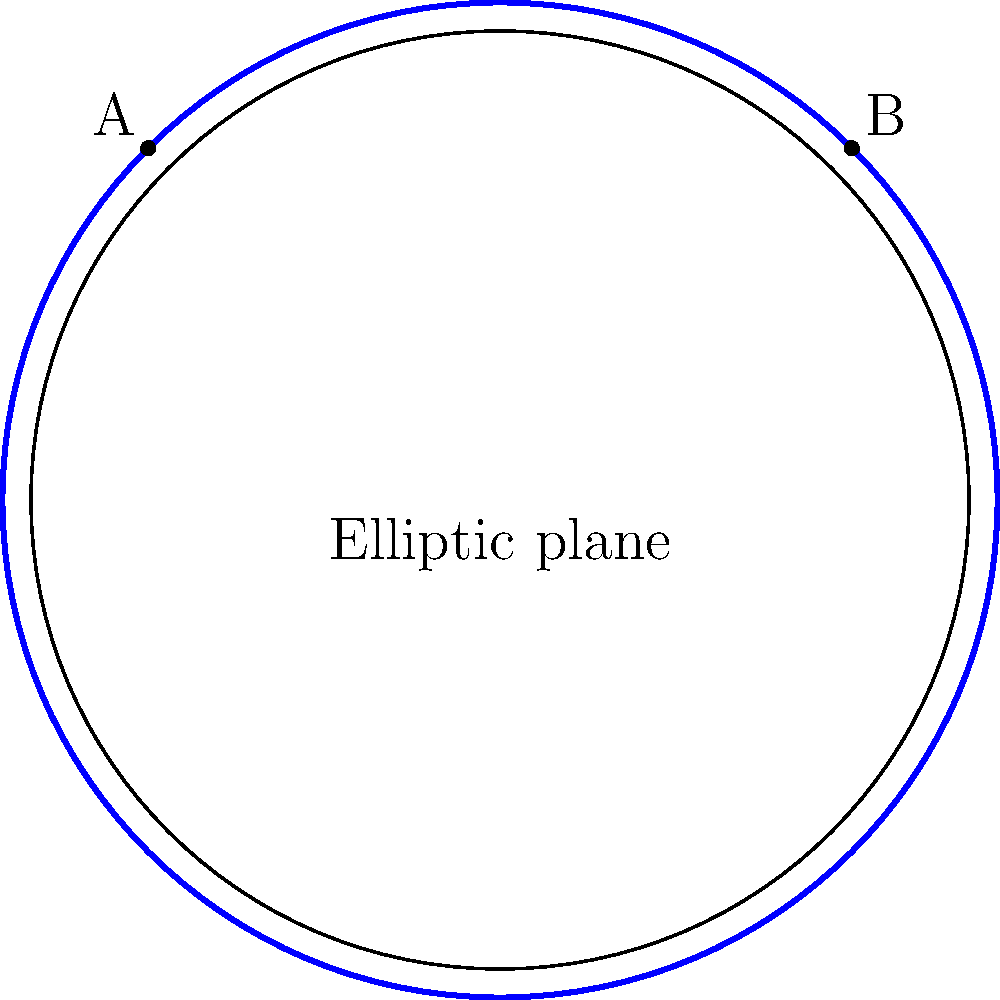As a personal concierge, you're planning a unique geometric-themed event. In elliptic geometry, represented by the surface of a sphere, how many distinct parallel lines can be drawn through point A that are parallel to the line passing through point B? To answer this question, let's consider the properties of elliptic geometry:

1. Elliptic geometry is modeled on the surface of a sphere, where "lines" are great circles (circles with the same center as the sphere).

2. In Euclidean geometry, parallel lines never intersect. However, in elliptic geometry, this concept doesn't hold true.

3. Any two great circles on a sphere always intersect at two antipodal points.

4. The concept of parallelism, as we understand it in Euclidean geometry, doesn't exist in elliptic geometry.

5. Given any line (great circle) and a point not on that line, there are no lines passing through the point that do not intersect the given line.

Therefore, in elliptic geometry:

- There are no parallel lines.
- Any line drawn through point A will inevitably intersect the line passing through point B at two points on the sphere.

This unique property of elliptic geometry could be an interesting talking point for your geometric-themed event, highlighting how different geometric systems can challenge our everyday understanding of space.
Answer: 0 (zero) 